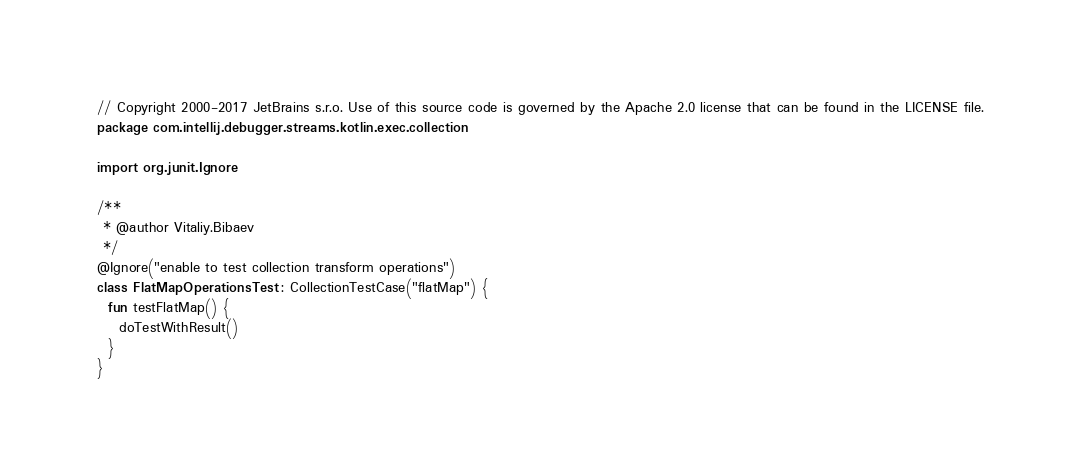<code> <loc_0><loc_0><loc_500><loc_500><_Kotlin_>// Copyright 2000-2017 JetBrains s.r.o. Use of this source code is governed by the Apache 2.0 license that can be found in the LICENSE file.
package com.intellij.debugger.streams.kotlin.exec.collection

import org.junit.Ignore

/**
 * @author Vitaliy.Bibaev
 */
@Ignore("enable to test collection transform operations")
class FlatMapOperationsTest : CollectionTestCase("flatMap") {
  fun testFlatMap() {
    doTestWithResult()
  }
}</code> 